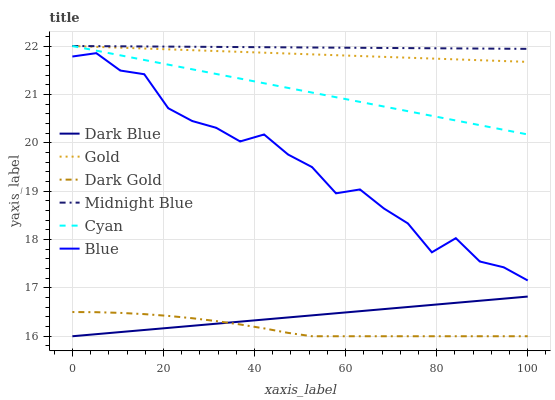Does Dark Gold have the minimum area under the curve?
Answer yes or no. Yes. Does Midnight Blue have the maximum area under the curve?
Answer yes or no. Yes. Does Gold have the minimum area under the curve?
Answer yes or no. No. Does Gold have the maximum area under the curve?
Answer yes or no. No. Is Cyan the smoothest?
Answer yes or no. Yes. Is Blue the roughest?
Answer yes or no. Yes. Is Midnight Blue the smoothest?
Answer yes or no. No. Is Midnight Blue the roughest?
Answer yes or no. No. Does Gold have the lowest value?
Answer yes or no. No. Does Cyan have the highest value?
Answer yes or no. Yes. Does Dark Gold have the highest value?
Answer yes or no. No. Is Dark Gold less than Cyan?
Answer yes or no. Yes. Is Gold greater than Blue?
Answer yes or no. Yes. Does Dark Gold intersect Cyan?
Answer yes or no. No. 